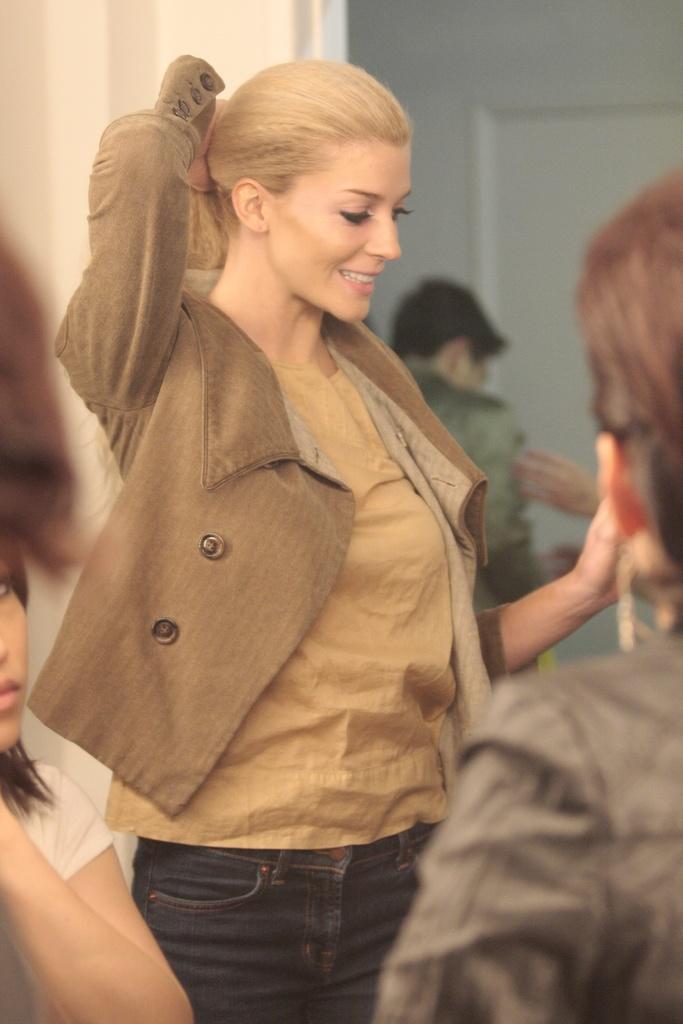Can you describe this image briefly? Here we can see a woman and she is smiling. There are few persons. In the background we can see wall. 